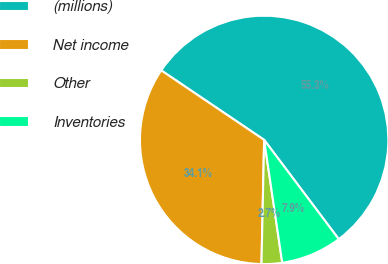Convert chart to OTSL. <chart><loc_0><loc_0><loc_500><loc_500><pie_chart><fcel>(millions)<fcel>Net income<fcel>Other<fcel>Inventories<nl><fcel>55.29%<fcel>34.11%<fcel>2.67%<fcel>7.93%<nl></chart> 